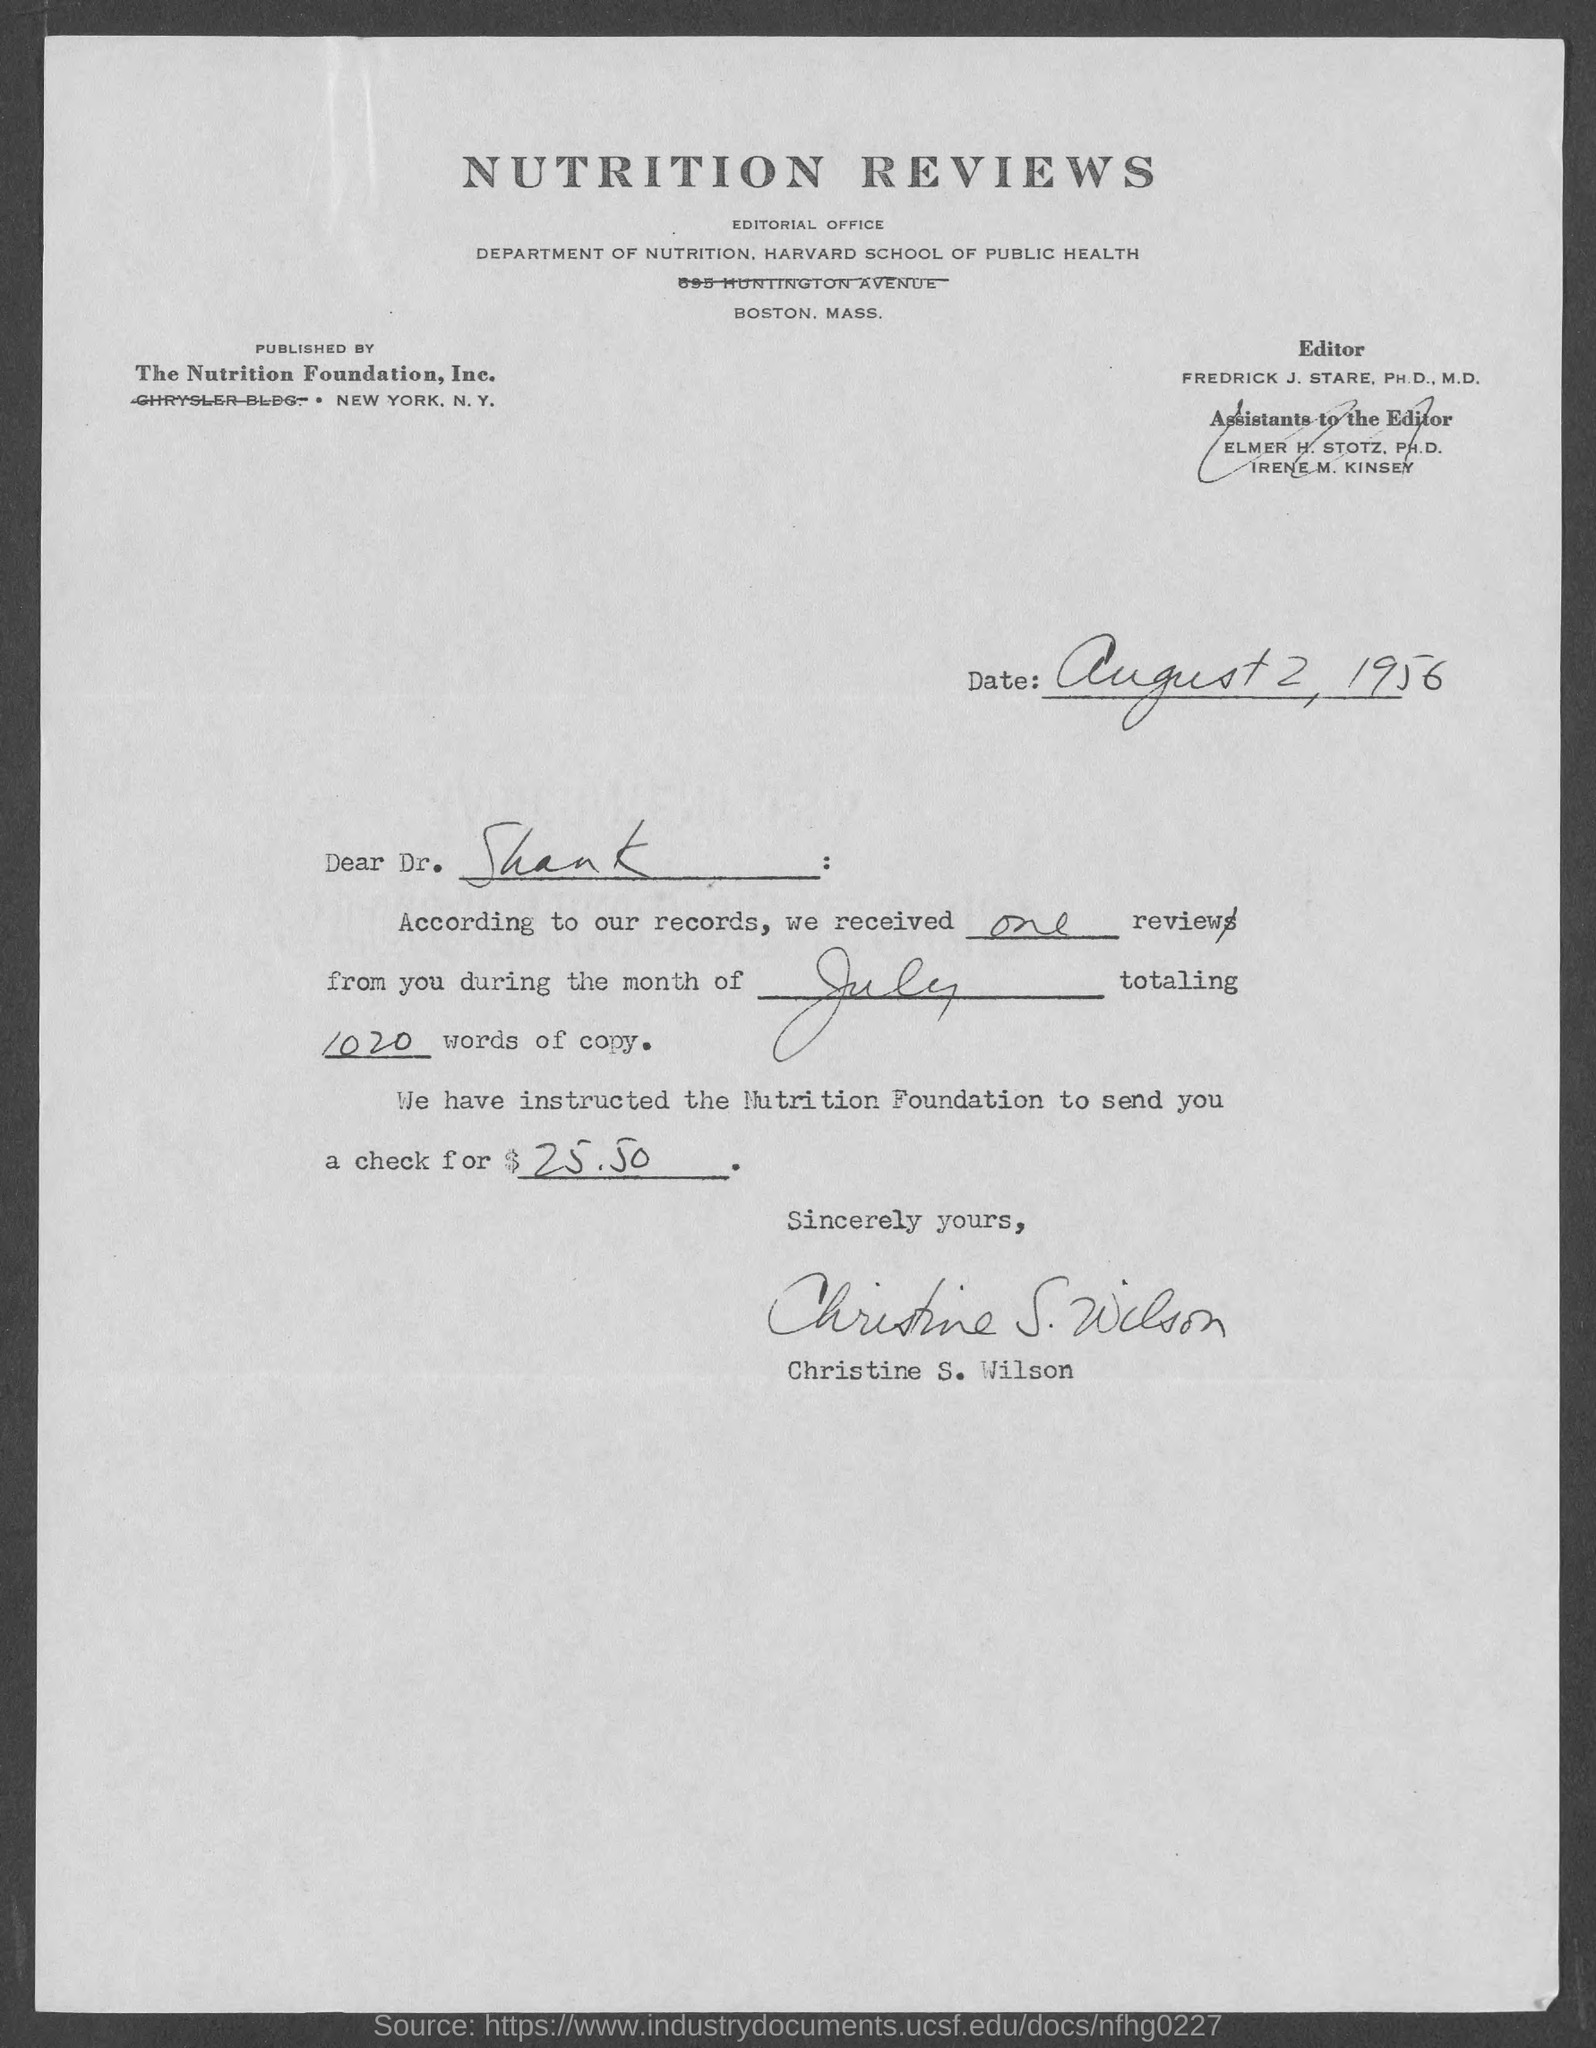What is the date mentioned ?
Give a very brief answer. August 2 , 1956. To whom this letter is sent ?
Offer a terse response. Dr. Shank. We received reviews from you during the month of ?
Offer a terse response. JULY. How much is the totaling words of copy ?
Keep it short and to the point. 1020. They have instructed the nutrition foundation to send you a check of how much amount ?
Make the answer very short. $25.50. This letter is written by whom ?
Keep it short and to the point. CHRISTINE S. WILSON. 